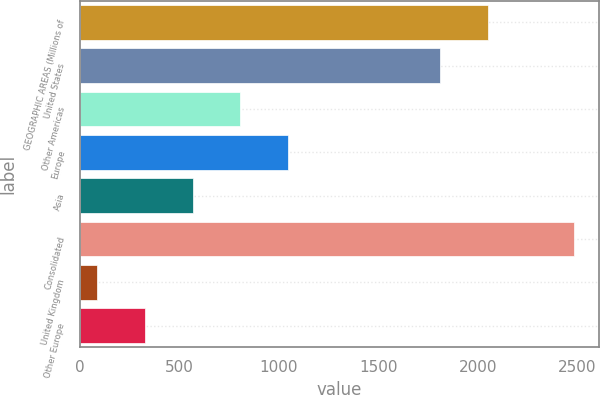Convert chart. <chart><loc_0><loc_0><loc_500><loc_500><bar_chart><fcel>GEOGRAPHIC AREAS (Millions of<fcel>United States<fcel>Other Americas<fcel>Europe<fcel>Asia<fcel>Consolidated<fcel>United Kingdom<fcel>Other Europe<nl><fcel>2050.64<fcel>1810.7<fcel>805.92<fcel>1045.86<fcel>565.98<fcel>2485.5<fcel>86.1<fcel>326.04<nl></chart> 